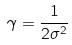<formula> <loc_0><loc_0><loc_500><loc_500>\gamma = \frac { 1 } { 2 \sigma ^ { 2 } }</formula> 